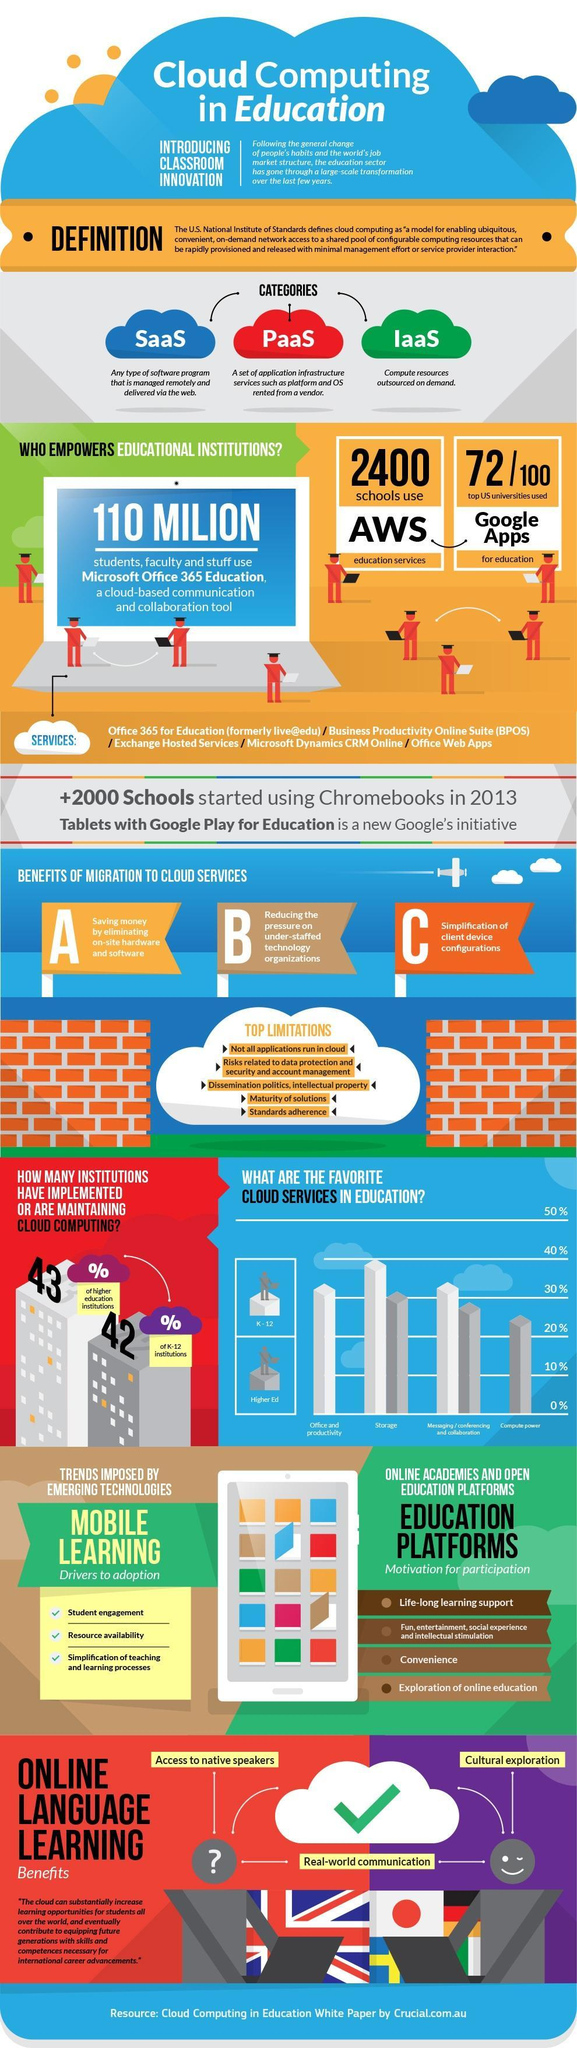How many students, faculty, and staff use Microsoft Office 365 for education?
Answer the question with a short phrase. 110 million How many schools use AWS education services? 2400 Out of 100, how many top US universities are not using google apps for education? 28 